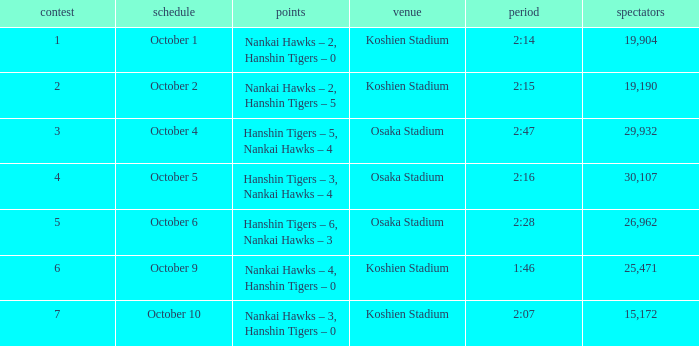How many games had a Time of 2:14? 1.0. 